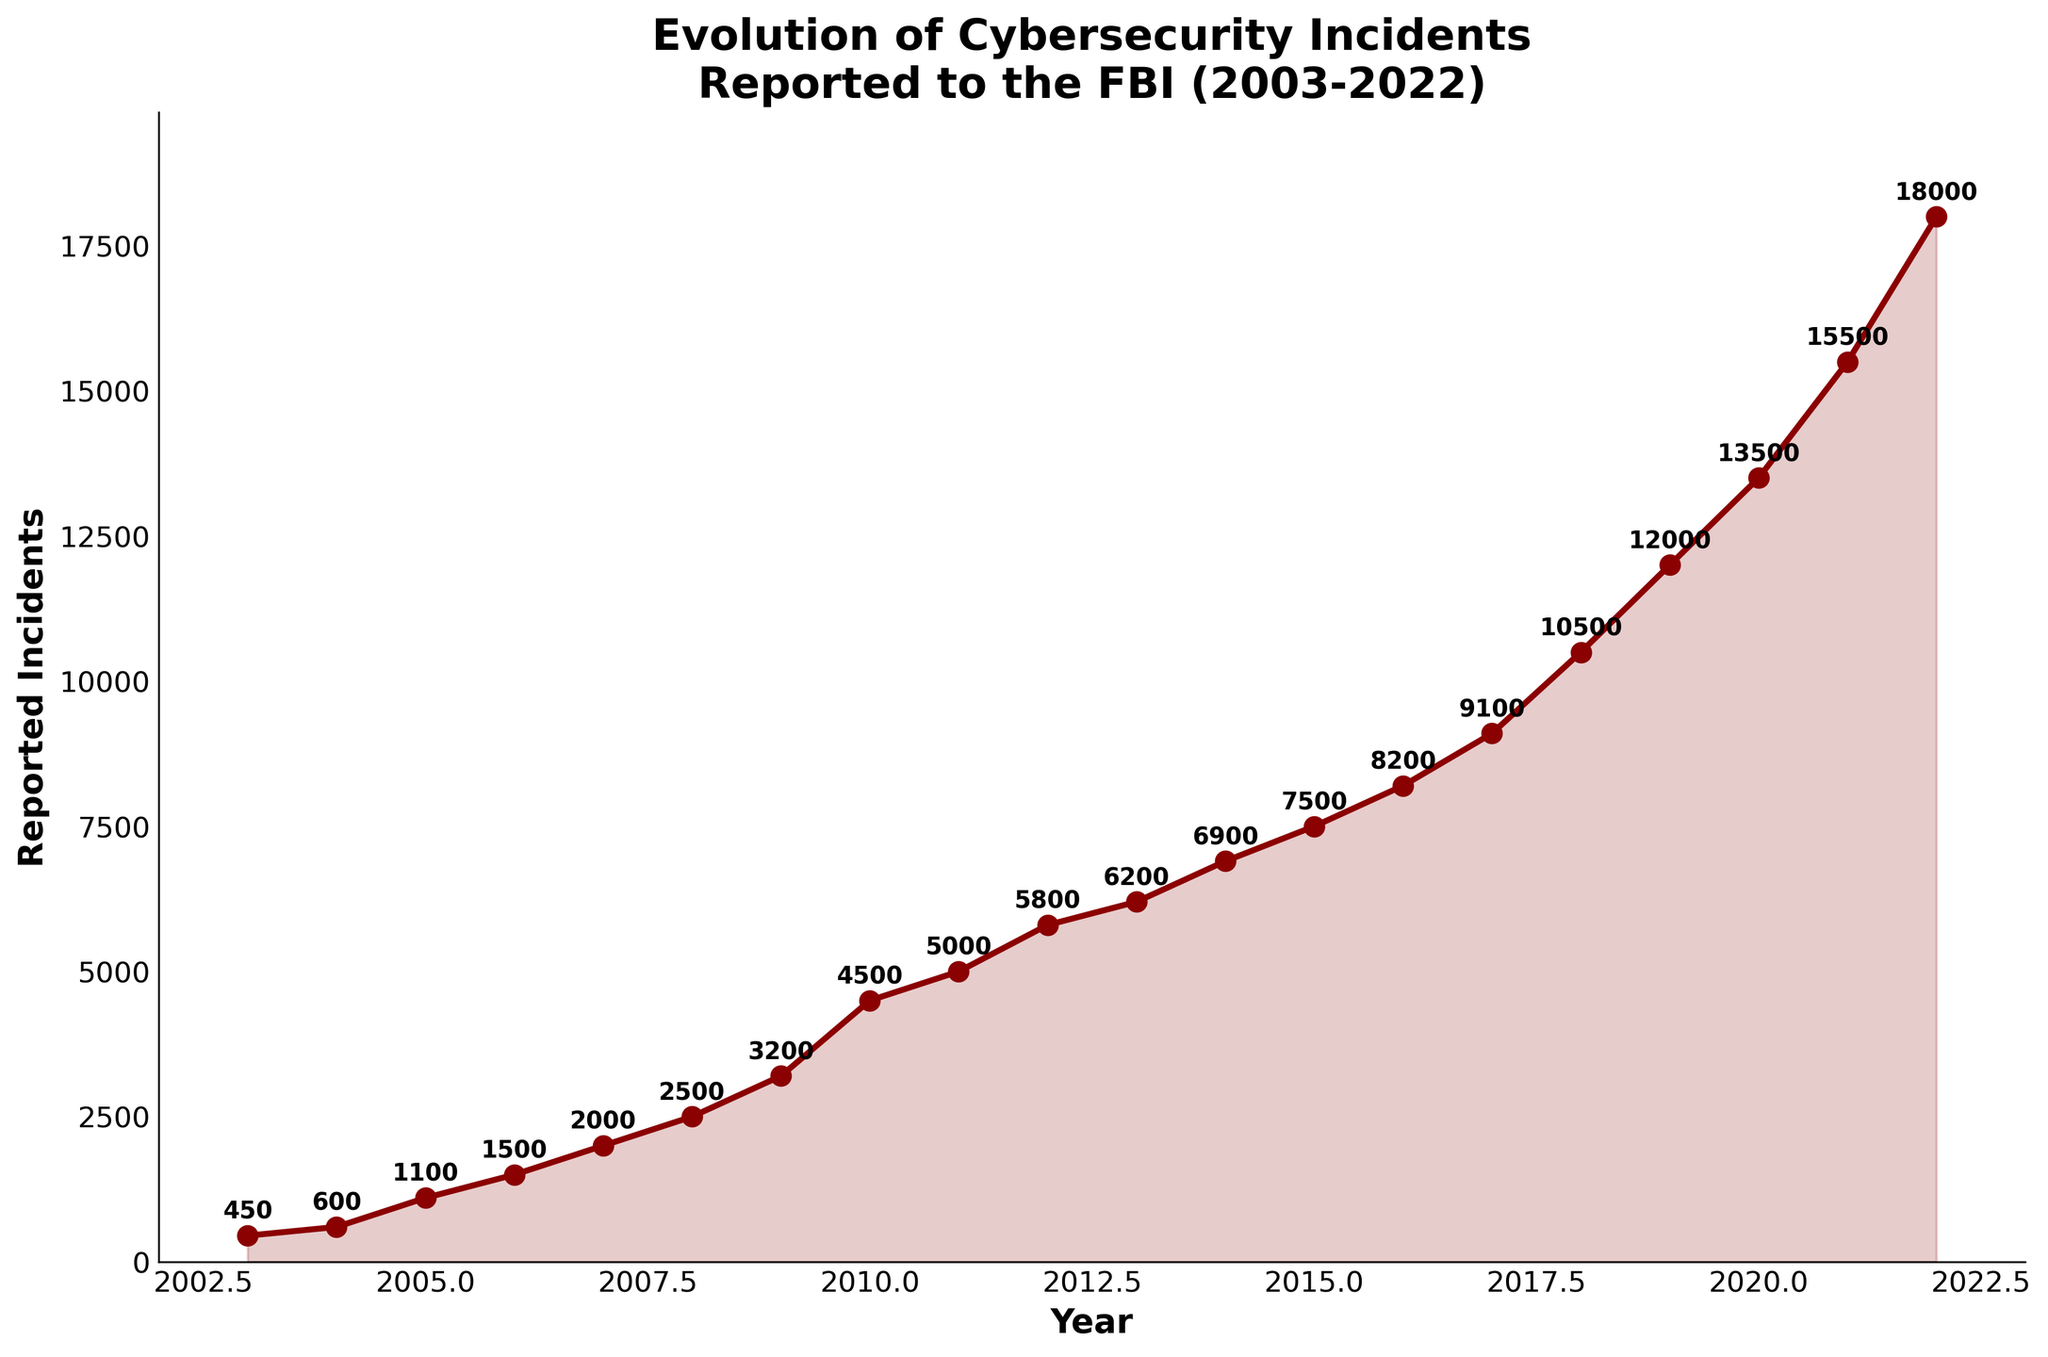What's the title of the figure? The title of the figure is found at the top and it usually describes what the chart is about.
Answer: Evolution of Cybersecurity Incidents Reported to the FBI (2003-2022) How many data points are represented in the figure? The data points can be counted by noting each year and its corresponding incident value plotted on the curve.
Answer: 20 What is the value of reported incidents in 2010? You can find the value of reported incidents by locating the year 2010 on the x-axis and checking the corresponding y-axis value.
Answer: 4500 What is the difference in reported incidents between 2008 and 2022? To find the difference, subtract the number of incidents in 2008 from the number of incidents in 2022. 18000 (2022) - 2500 (2008) = 15500
Answer: 15500 How many years show an increase in reported incidents compared to the previous year? Count the number of years where the reported incidents are higher than the previous year's reported incidents. These include 2004, 2005, 2006, 2007, 2008, 2009, 2010, 2011, 2012, 2013, 2014, 2015, 2016, 2017, 2018, 2019, 2020, 2021, 2022. There are no years with a decrease.
Answer: 19 Between which years did the number of reported incidents first exceed 10,000? Identify the years just before and after the number of reported incidents exceeded 10,000, which are 2017 and 2018.
Answer: 2017 and 2018 What is the average number of reported incidents from 2018 to 2022? Add the number of reported incidents for the years 2018, 2019, 2020, 2021, and 2022, then divide by 5: (10500 + 12000 + 13500 + 15500 + 18000) / 5 = 13900
Answer: 13900 During which year did the number of reported incidents reach its highest value? Find the year corresponding to the highest point on the plot, which is in 2022.
Answer: 2022 What is the difference in the number of reported incidents between the first and the last year in the dataset? Subtract the number of incidents reported in 2003 from the number reported in 2022: 18000 (2022) - 450 (2003) = 17550
Answer: 17550 Did any year show a decrease in reported incidents compared to the previous year? Observe the plot to see if there is any year where the line trends downward. There is no year where the reported incidents decrease compared to the previous year.
Answer: No 